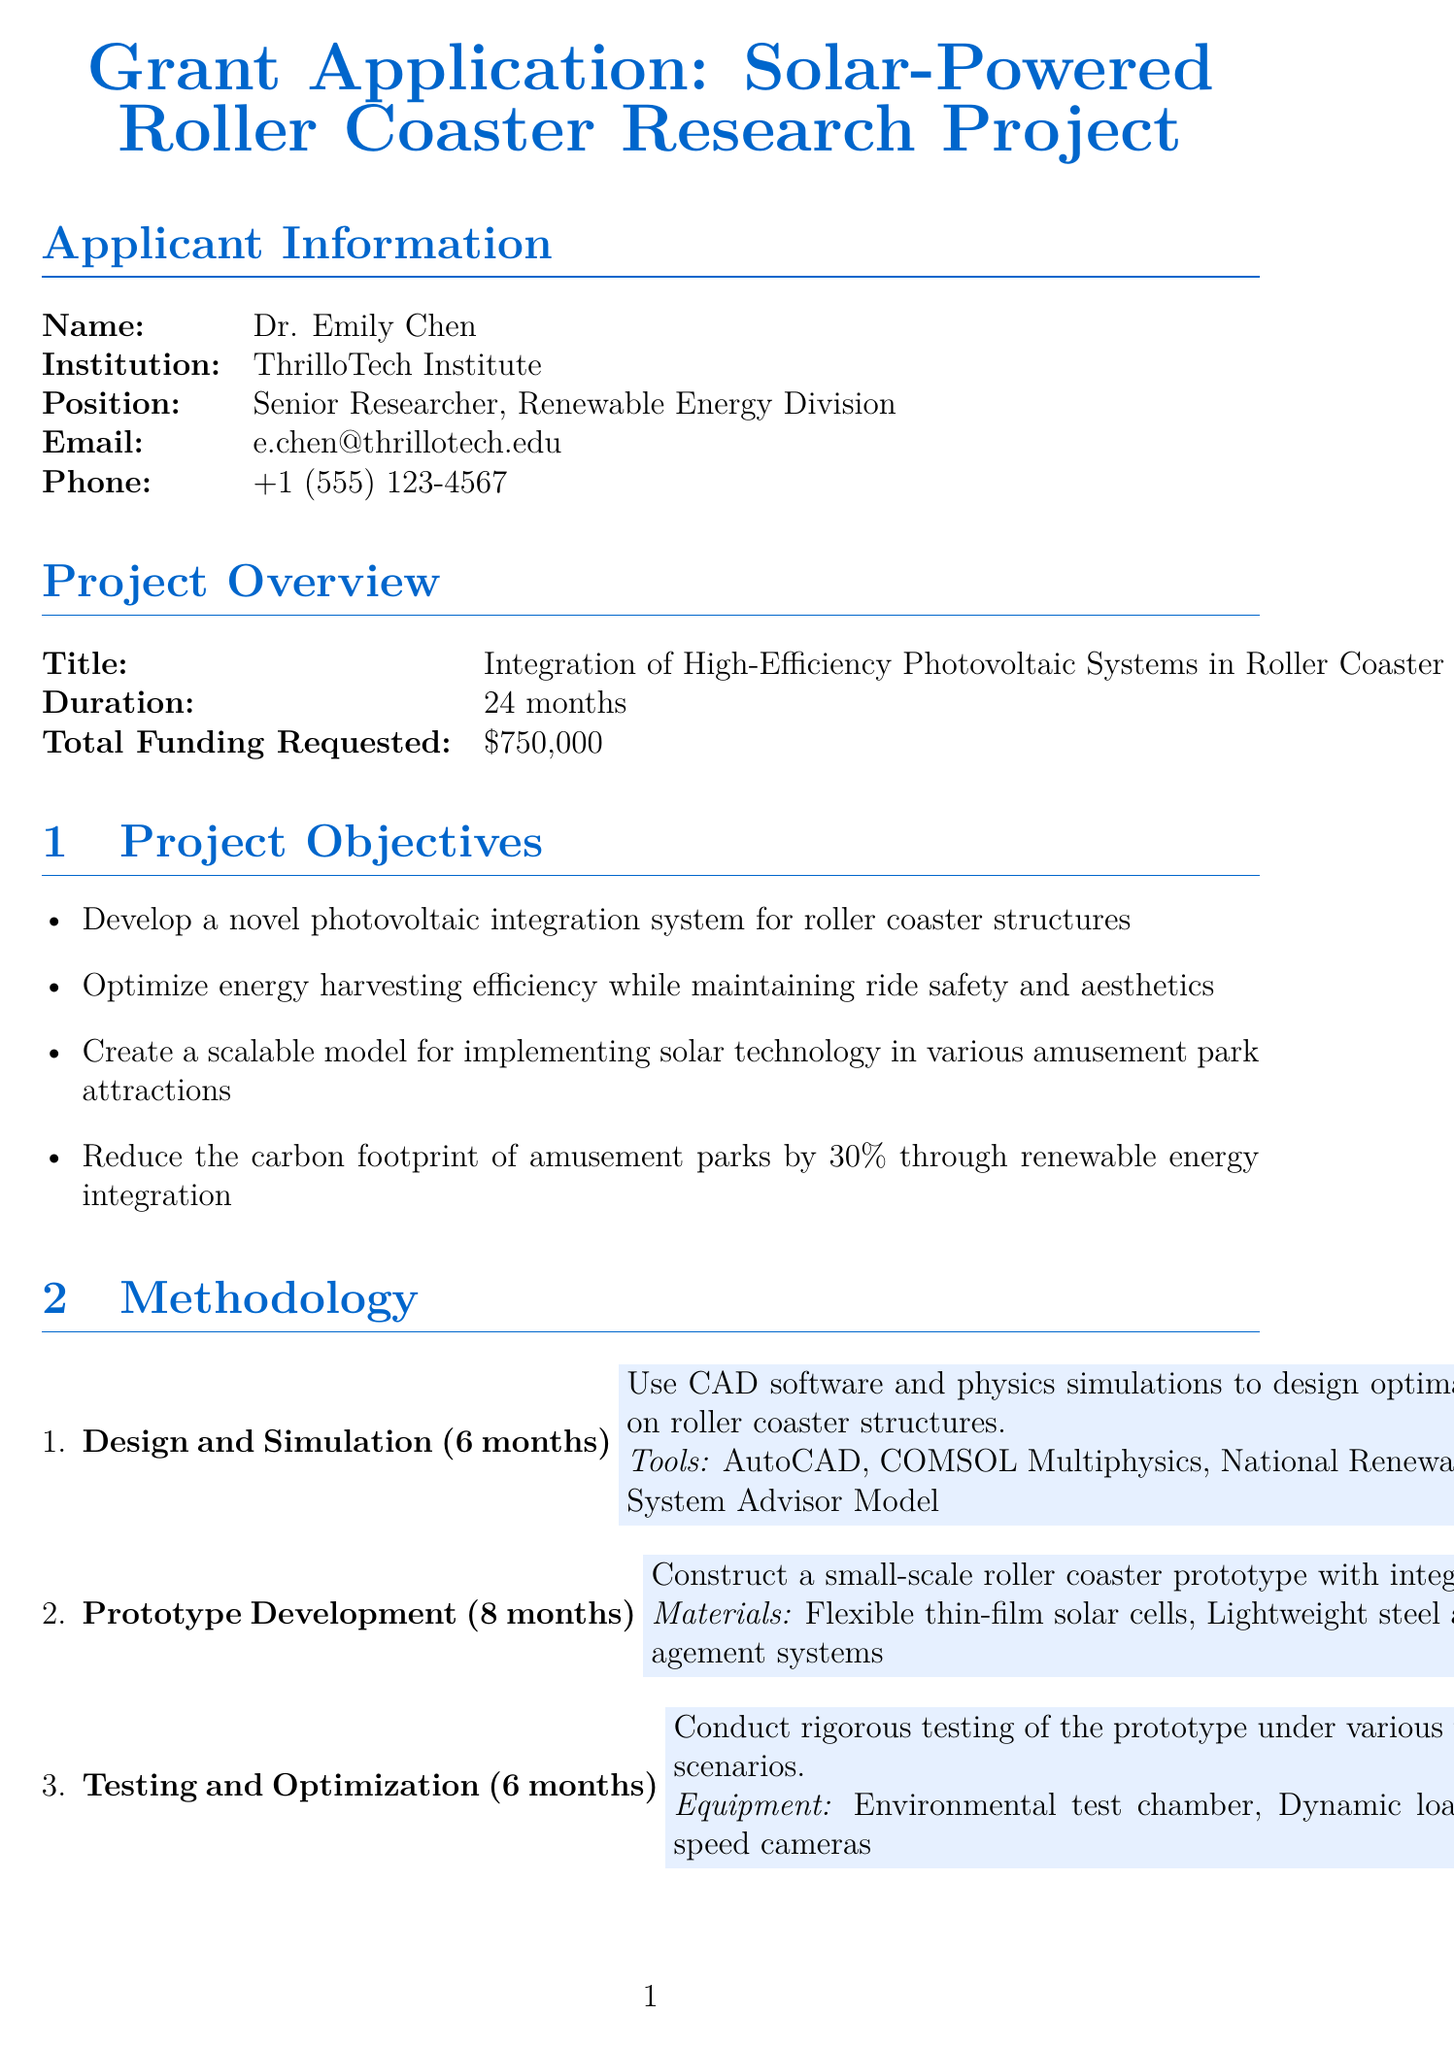What is the name of the principal investigator? The principal investigator's name is listed under the applicant information section.
Answer: Dr. Emily Chen What is the total funding requested for the project? The total funding requested is stated in the project overview section.
Answer: $750,000 What is the duration of the project? The duration is specified in the project overview section.
Answer: 24 months What are the two main tools used in the Design and Simulation phase? The tools for this phase are listed in the methodology section.
Answer: AutoCAD, COMSOL Multiphysics How many months are allocated for Prototype Development? The duration for Prototype Development is provided in the methodology section.
Answer: 8 months What is one of the expected outcomes of this project? Expected outcomes are mentioned in a specific section and can include several items.
Answer: A validated model for integrating solar panels into roller coaster structures Who is the industry partner for real-world testing? The collaborator section lists this information.
Answer: ThrillRide Amusement Parks, Inc How much is allocated for computational resources? The budget section clearly outlines the amount for each category.
Answer: $40,000 What ethical consideration addresses safety regulations? This information is listed among the ethical considerations in a distinct section.
Answer: Ensure all testing adheres to safety regulations for amusement park rides 